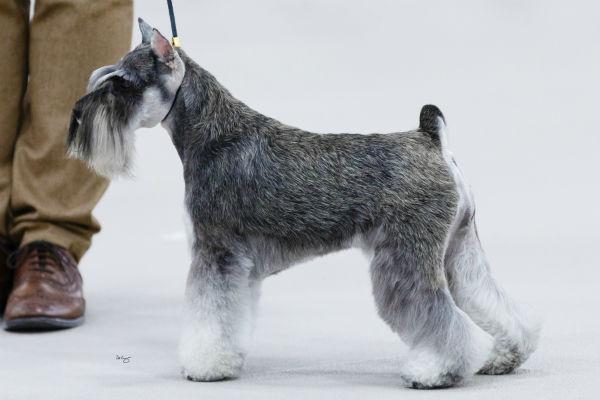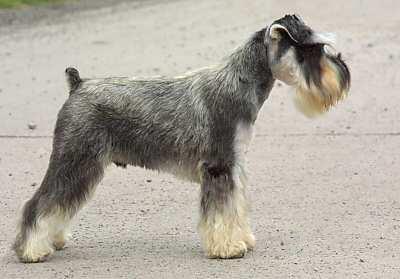The first image is the image on the left, the second image is the image on the right. Examine the images to the left and right. Is the description "One dog's body is facing to the left." accurate? Answer yes or no. Yes. The first image is the image on the left, the second image is the image on the right. Considering the images on both sides, is "An image shows exactly one schnauzer, which stands on all fours facing leftward." valid? Answer yes or no. Yes. 